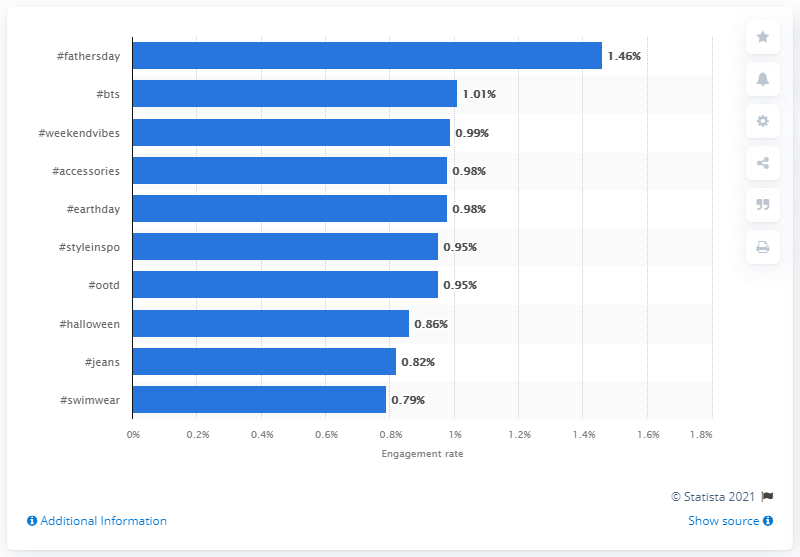List a handful of essential elements in this visual. In 2019, the engagement rate of the #ootd (outfit of the day) tag on Instagram was 0.95. 